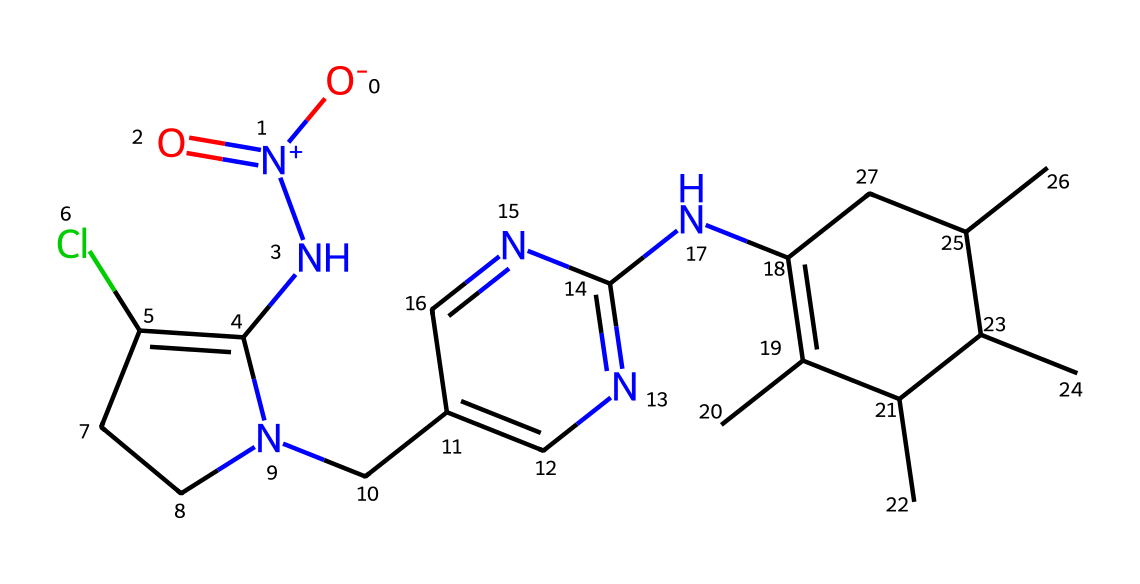What is the molecular formula of imidacloprid? By analyzing the SMILES representation, we can count the different types of atoms present. The formula includes carbon (C), hydrogen (H), nitrogen (N), and chlorine (Cl). Through counting, we determine it is C9H10ClN5O2.
Answer: C9H10ClN5O2 How many nitrogen atoms are present in the structure? By inspecting the SMILES string, we can identify the nitrogen (N) atoms. In the representation, we can visually trace the number and confirm that there are five nitrogen atoms.
Answer: 5 What type of functional groups does imidacloprid contain? In the SMILES representation, we see amine (NH) and nitro (NO2) functional groups. The arrangement includes a nitro group (indicated by O=N(=O)) and the presence of nitrogen connecting to the cyclic structure indicates an amine.
Answer: amine, nitro Which part of the structure contributes to its insecticidal activity? The neonicotinoid structure, including the presence of multiple nitrogen atoms that allow binding to nicotinic acetylcholine receptors (nAChRs) in insects, is crucial. This structure mimics the neurotransmitter acetylcholine, leading to its activity.
Answer: neonicotinoid structure How many rings are present in the molecular structure? By examining the complex structure within the SMILES representation, there are two distinct cyclic compounds that can be identified, confirming that there are a total of two rings within the molecule.
Answer: 2 What is the overall charge of the imidacloprid molecule? The structure of imidacloprid, while neutral in terms of the overall chemical representation, has a positive charge contributed by the ammonium part of its structure, particularly in the nitrogen atoms' connections.
Answer: neutral 